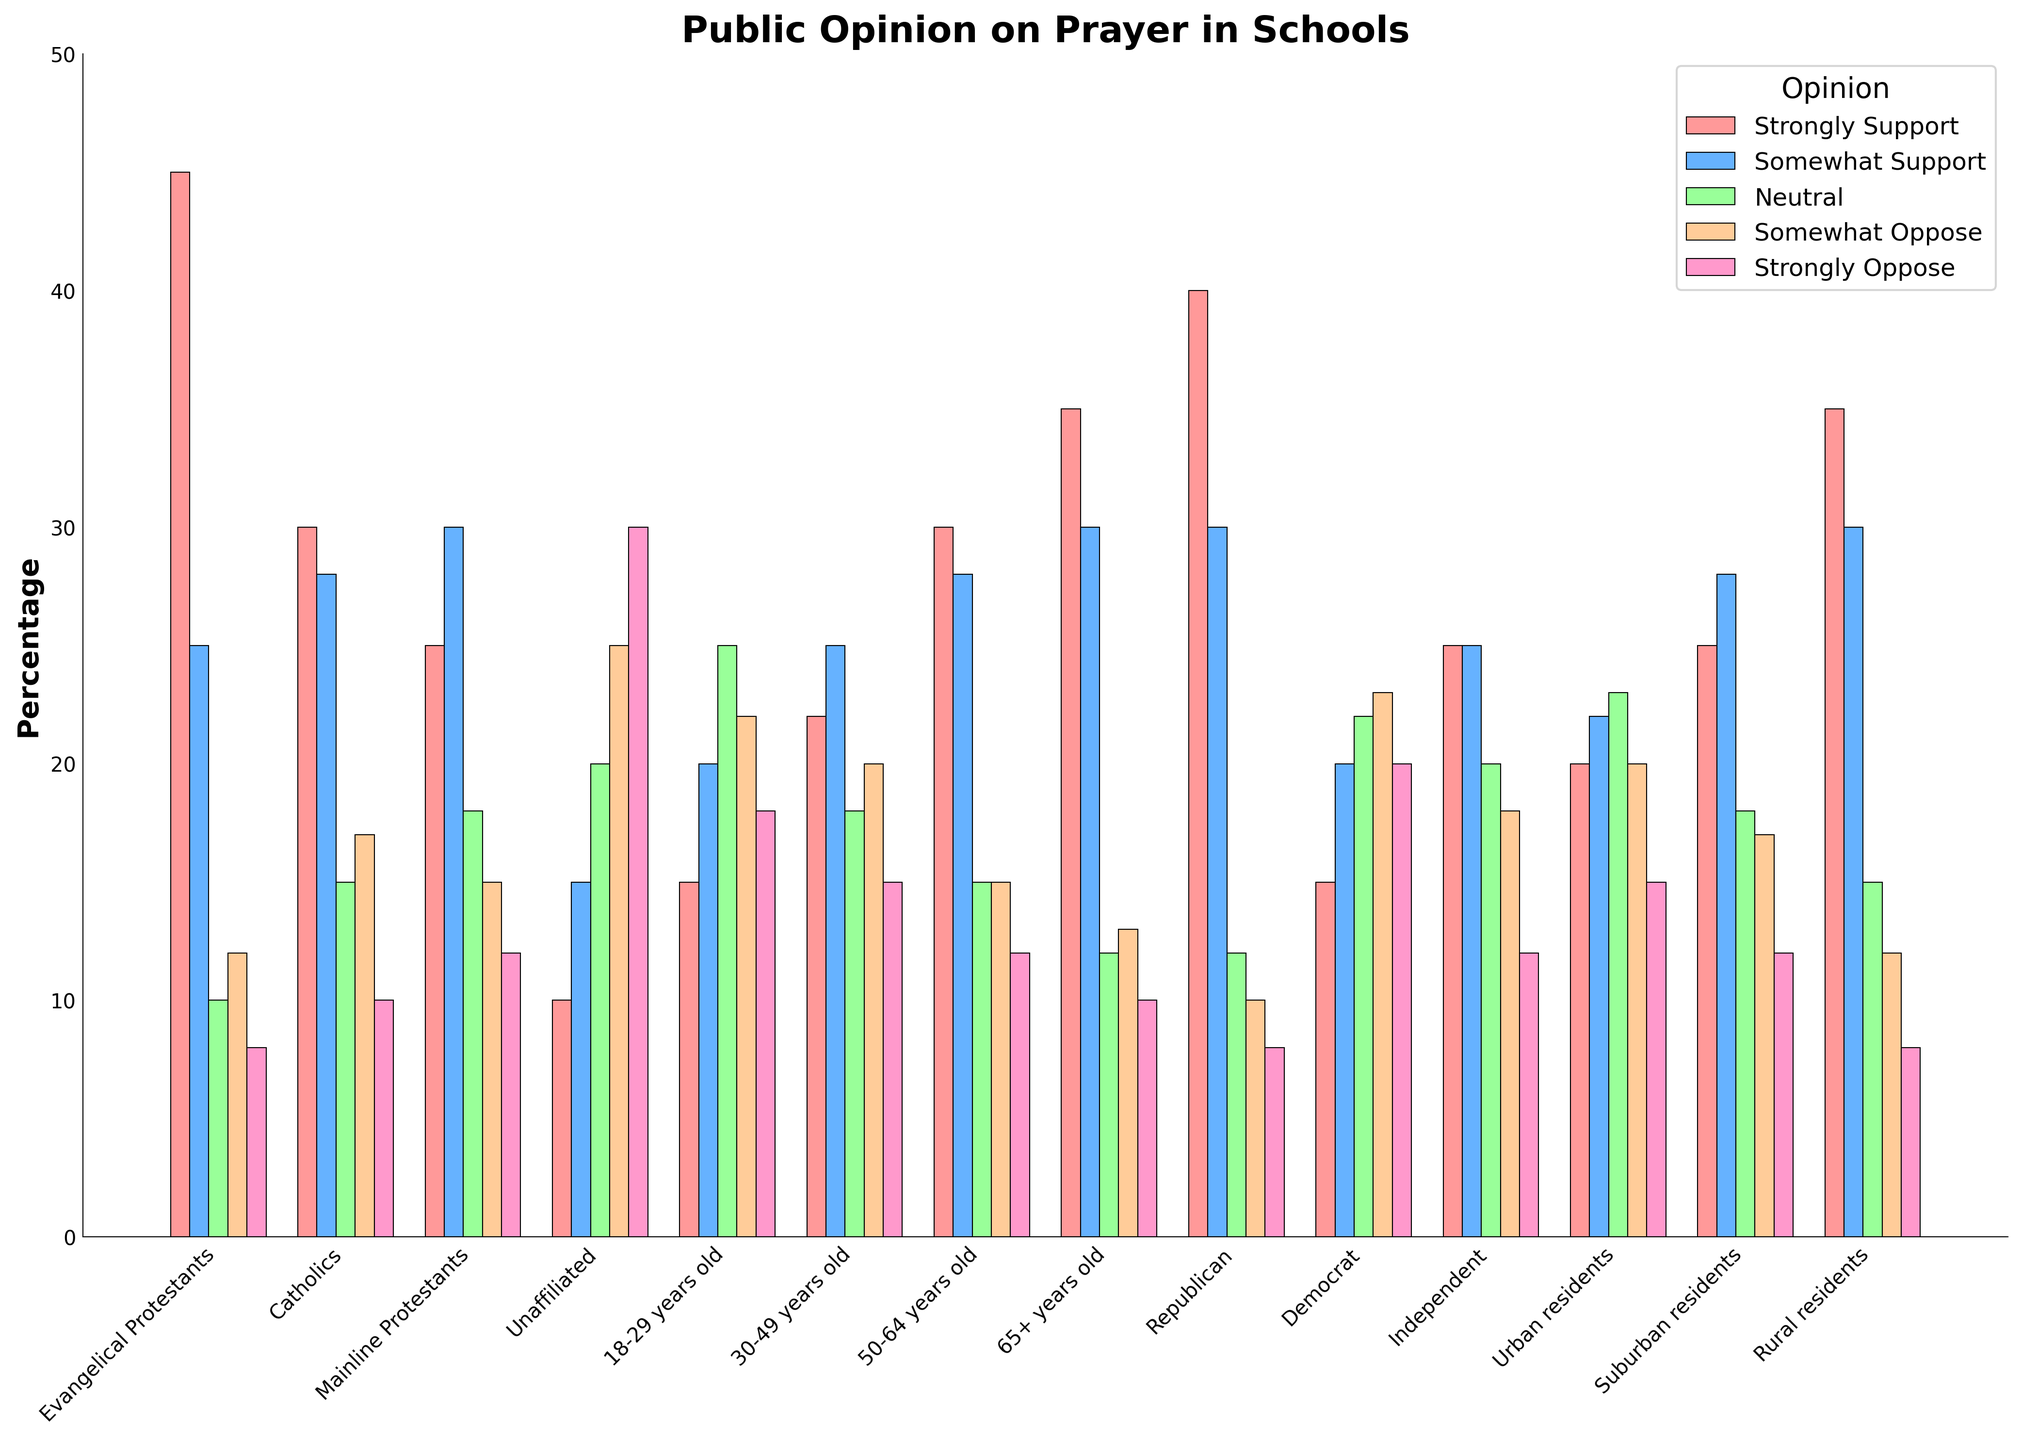Which group shows the highest percentage of "Strongly Support" for prayer in schools? The bar representing "Strongly Support" for each group is compared visually. The group with the tallest bar for "Strongly Support" is identified.
Answer: Evangelical Protestants Which demographic is least likely to "Strongly Oppose" prayer in schools? Visually compare the heights of all the "Strongly Oppose" bars to identify the smallest one.
Answer: Evangelical Protestants and Rural residents What is the total percentage of people who "Support" (both Strongly and Somewhat) prayer in schools among Democrats? Sum the percentages of "Strongly Support" and "Somewhat Support" for the Democrat group: 15 + 20.
Answer: 35 How do urban residents' opinions on prayer in schools compare to rural residents in terms of "Neutral"? Compare the heights of the "Neutral" bar for Urban residents and Rural residents.
Answer: Urban residents are higher Which age group has the largest "Somewhat Oppose" percentage? Compare the heights of the "Somewhat Oppose" bars across all age groups.
Answer: 18-29 years old What is the average percentage of "Strongly Oppose" across all groups? Sum the "Strongly Oppose" percentages for all groups and divide by the number of groups: (8+10+12+30+18+15+12+10+8+20+12+15+12+8)/14.
Answer: 15 Is there any group where the percentage of "Strongly Support" and "Strongly Oppose" is equal? Compare the heights of "Strongly Support" and "Strongly Oppose" bars within each group.
Answer: No How do the support percentages (both Strongly and Somewhat) of Catholics compare to Mainline Protestants? Sum the "Strongly Support" and "Somewhat Support" percentages for both groups and compare: Catholics (30 + 28) vs. Mainline Protestants (25 + 30).
Answer: Catholics: 58, Mainline Protestants: 55 What percentage of Unaffiliated people are either "Neutral" or "Somewhat Oppose" to prayer in schools? Sum the percentages for "Neutral" and "Somewhat Oppose" within the Unaffiliated group: 20 + 25.
Answer: 45 Which political affiliation has the highest percentage of "Strongly Support" for prayer in schools? Compare the heights of the "Strongly Support" bars for each political affiliation.
Answer: Republican 